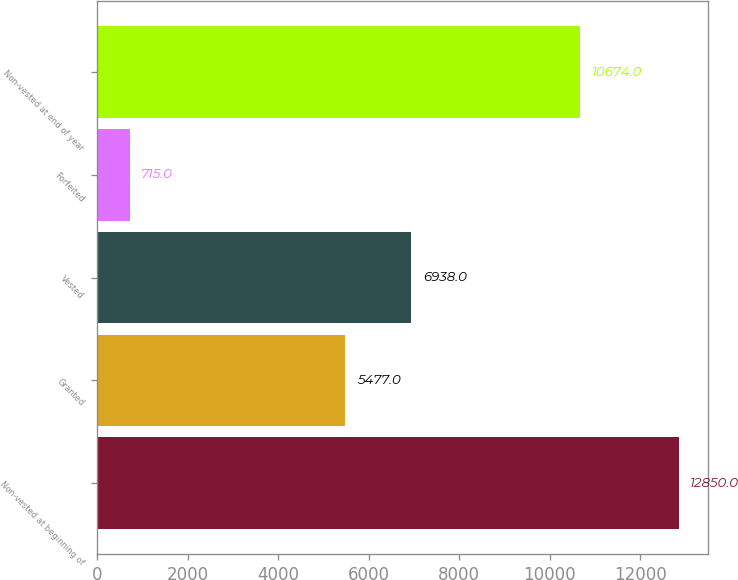Convert chart to OTSL. <chart><loc_0><loc_0><loc_500><loc_500><bar_chart><fcel>Non-vested at beginning of<fcel>Granted<fcel>Vested<fcel>Forfeited<fcel>Non-vested at end of year<nl><fcel>12850<fcel>5477<fcel>6938<fcel>715<fcel>10674<nl></chart> 